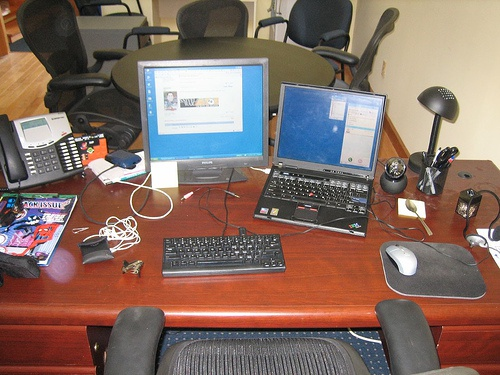Describe the objects in this image and their specific colors. I can see chair in maroon, gray, black, and blue tones, laptop in maroon, blue, black, lightgray, and gray tones, tv in maroon, white, lightblue, darkgray, and gray tones, chair in maroon, black, and gray tones, and dining table in maroon, gray, black, and darkgray tones in this image. 